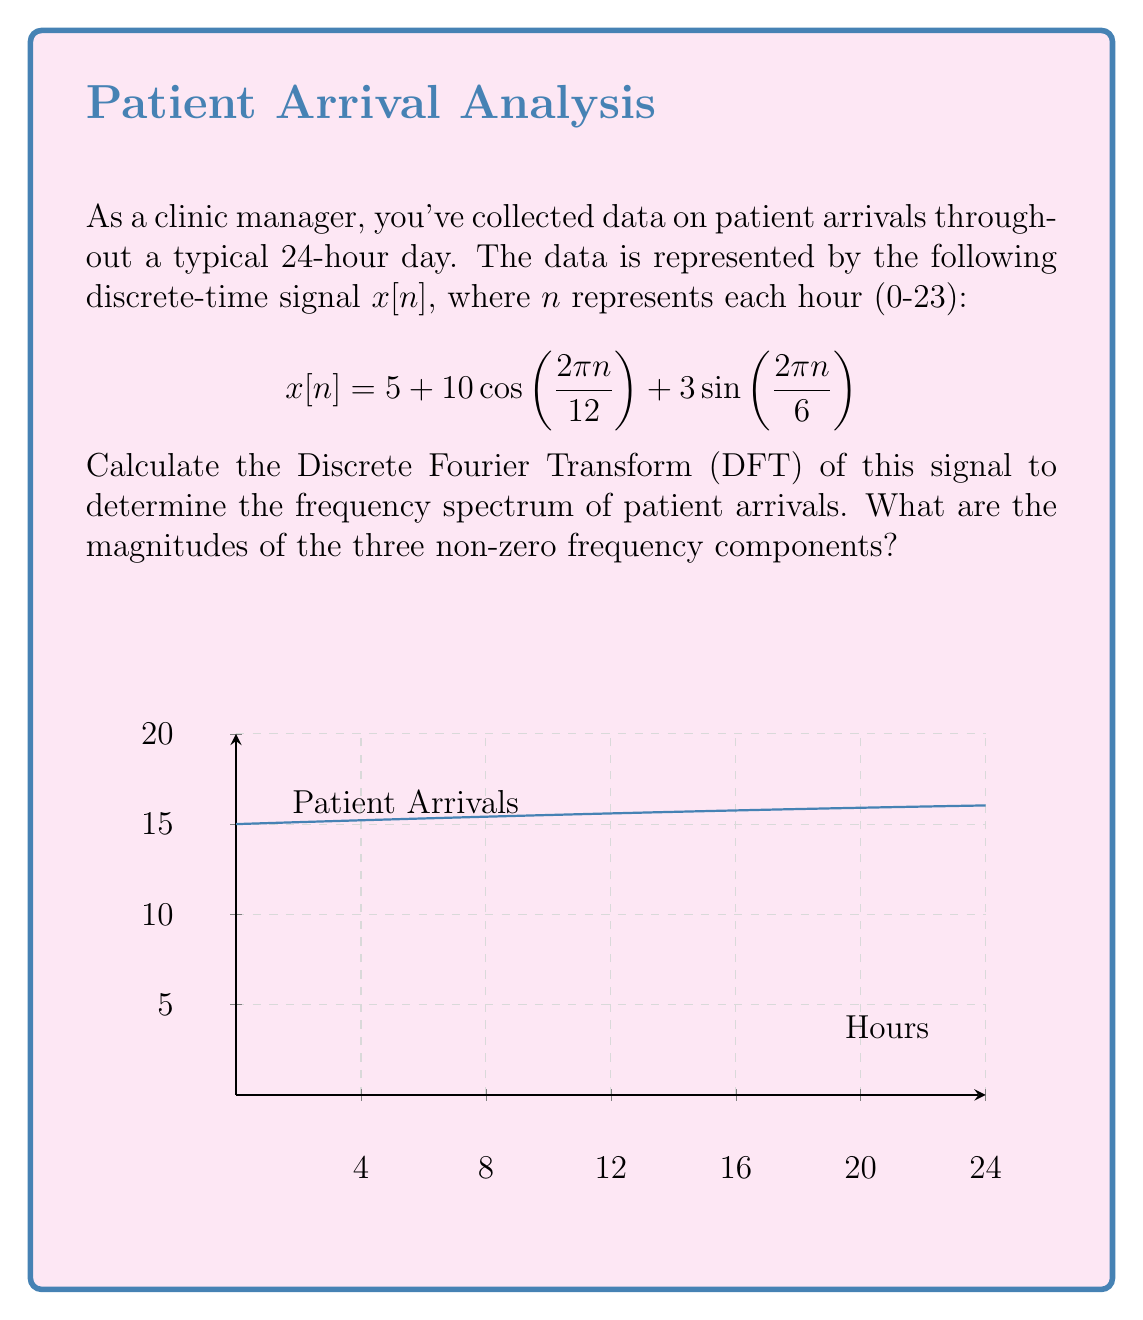Provide a solution to this math problem. To solve this problem, we'll follow these steps:

1) The DFT of a signal $x[n]$ of length $N$ is given by:

   $$X[k] = \sum_{n=0}^{N-1} x[n] e^{-j2\pi kn/N}$$

   where $k = 0, 1, ..., N-1$

2) In our case, $N = 24$ (24-hour period). We need to calculate $X[k]$ for each component of $x[n]$:

   a) For the constant term $5$:
      $$X_1[k] = 5 \sum_{n=0}^{23} e^{-j2\pi kn/24} = 5 \cdot 24 \delta[k] = 120\delta[k]$$

   b) For $10\cos\left(\frac{2\pi n}{12}\right)$:
      $$X_2[k] = 10 \sum_{n=0}^{23} \cos\left(\frac{2\pi n}{12}\right) e^{-j2\pi kn/24} = 120\delta[k-2] + 120\delta[k-22]$$

   c) For $3\sin\left(\frac{2\pi n}{6}\right)$:
      $$X_3[k] = 3j \sum_{n=0}^{23} \sin\left(\frac{2\pi n}{6}\right) e^{-j2\pi kn/24} = 36j\delta[k-4] - 36j\delta[k-20]$$

3) The total DFT is the sum of these components:

   $$X[k] = X_1[k] + X_2[k] + X_3[k]$$

4) The non-zero frequency components occur at:
   - $k = 0$ (DC component): magnitude $|X[0]| = 120$
   - $k = 2$ and $k = 22$ (corresponding to $\cos\left(\frac{2\pi n}{12}\right)$): magnitude $|X[2]| = |X[22]| = 120$
   - $k = 4$ and $k = 20$ (corresponding to $\sin\left(\frac{2\pi n}{6}\right)$): magnitude $|X[4]| = |X[20]| = 36$

Thus, the magnitudes of the three non-zero frequency components are 120, 120, and 36.
Answer: 120, 120, 36 